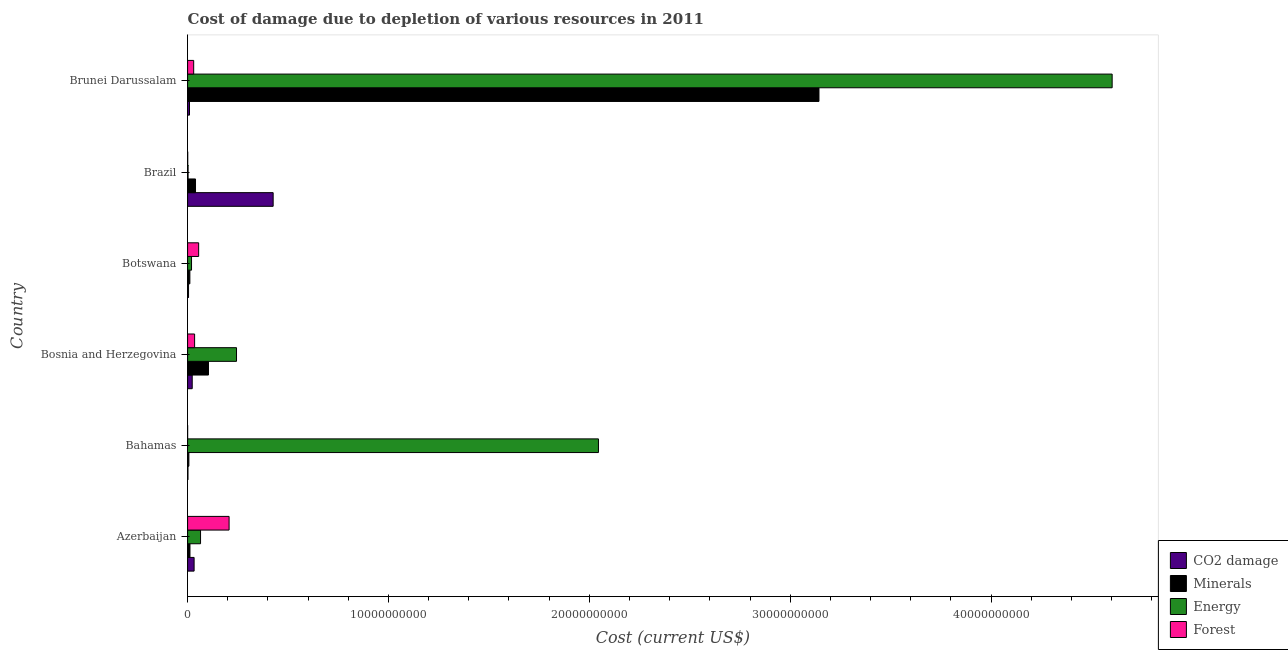Are the number of bars per tick equal to the number of legend labels?
Provide a succinct answer. Yes. How many bars are there on the 1st tick from the top?
Keep it short and to the point. 4. What is the label of the 2nd group of bars from the top?
Offer a terse response. Brazil. In how many cases, is the number of bars for a given country not equal to the number of legend labels?
Your answer should be very brief. 0. What is the cost of damage due to depletion of energy in Brunei Darussalam?
Provide a short and direct response. 4.60e+1. Across all countries, what is the maximum cost of damage due to depletion of forests?
Ensure brevity in your answer.  2.07e+09. Across all countries, what is the minimum cost of damage due to depletion of energy?
Keep it short and to the point. 2.37e+07. In which country was the cost of damage due to depletion of minerals maximum?
Your answer should be very brief. Brunei Darussalam. In which country was the cost of damage due to depletion of forests minimum?
Ensure brevity in your answer.  Bahamas. What is the total cost of damage due to depletion of minerals in the graph?
Offer a terse response. 3.32e+1. What is the difference between the cost of damage due to depletion of coal in Botswana and that in Brunei Darussalam?
Your response must be concise. -4.74e+07. What is the difference between the cost of damage due to depletion of coal in Botswana and the cost of damage due to depletion of energy in Brunei Darussalam?
Provide a short and direct response. -4.60e+1. What is the average cost of damage due to depletion of minerals per country?
Provide a succinct answer. 5.53e+09. What is the difference between the cost of damage due to depletion of energy and cost of damage due to depletion of forests in Brunei Darussalam?
Make the answer very short. 4.57e+1. What is the ratio of the cost of damage due to depletion of forests in Azerbaijan to that in Brazil?
Your response must be concise. 326.15. Is the difference between the cost of damage due to depletion of energy in Azerbaijan and Brunei Darussalam greater than the difference between the cost of damage due to depletion of forests in Azerbaijan and Brunei Darussalam?
Give a very brief answer. No. What is the difference between the highest and the second highest cost of damage due to depletion of minerals?
Give a very brief answer. 3.04e+1. What is the difference between the highest and the lowest cost of damage due to depletion of coal?
Your answer should be compact. 4.24e+09. Is the sum of the cost of damage due to depletion of coal in Azerbaijan and Bosnia and Herzegovina greater than the maximum cost of damage due to depletion of energy across all countries?
Ensure brevity in your answer.  No. What does the 3rd bar from the top in Bahamas represents?
Offer a terse response. Minerals. What does the 1st bar from the bottom in Bosnia and Herzegovina represents?
Give a very brief answer. CO2 damage. How many bars are there?
Give a very brief answer. 24. Are all the bars in the graph horizontal?
Your answer should be very brief. Yes. How many countries are there in the graph?
Provide a succinct answer. 6. Does the graph contain any zero values?
Your answer should be very brief. No. Does the graph contain grids?
Your response must be concise. No. Where does the legend appear in the graph?
Offer a very short reply. Bottom right. How many legend labels are there?
Keep it short and to the point. 4. What is the title of the graph?
Your response must be concise. Cost of damage due to depletion of various resources in 2011 . Does "Periodicity assessment" appear as one of the legend labels in the graph?
Ensure brevity in your answer.  No. What is the label or title of the X-axis?
Offer a very short reply. Cost (current US$). What is the Cost (current US$) in CO2 damage in Azerbaijan?
Provide a short and direct response. 3.24e+08. What is the Cost (current US$) in Minerals in Azerbaijan?
Offer a terse response. 1.18e+08. What is the Cost (current US$) of Energy in Azerbaijan?
Your answer should be compact. 6.45e+08. What is the Cost (current US$) in Forest in Azerbaijan?
Provide a short and direct response. 2.07e+09. What is the Cost (current US$) of CO2 damage in Bahamas?
Your answer should be very brief. 1.85e+07. What is the Cost (current US$) in Minerals in Bahamas?
Provide a succinct answer. 6.40e+07. What is the Cost (current US$) in Energy in Bahamas?
Your answer should be very brief. 2.05e+1. What is the Cost (current US$) in Forest in Bahamas?
Provide a short and direct response. 1.39e+06. What is the Cost (current US$) in CO2 damage in Bosnia and Herzegovina?
Make the answer very short. 2.30e+08. What is the Cost (current US$) of Minerals in Bosnia and Herzegovina?
Give a very brief answer. 1.04e+09. What is the Cost (current US$) of Energy in Bosnia and Herzegovina?
Provide a short and direct response. 2.44e+09. What is the Cost (current US$) in Forest in Bosnia and Herzegovina?
Provide a succinct answer. 3.49e+08. What is the Cost (current US$) of CO2 damage in Botswana?
Offer a terse response. 4.71e+07. What is the Cost (current US$) of Minerals in Botswana?
Provide a short and direct response. 1.13e+08. What is the Cost (current US$) of Energy in Botswana?
Your answer should be compact. 1.96e+08. What is the Cost (current US$) in Forest in Botswana?
Provide a succinct answer. 5.51e+08. What is the Cost (current US$) in CO2 damage in Brazil?
Give a very brief answer. 4.26e+09. What is the Cost (current US$) of Minerals in Brazil?
Give a very brief answer. 3.94e+08. What is the Cost (current US$) in Energy in Brazil?
Offer a very short reply. 2.37e+07. What is the Cost (current US$) of Forest in Brazil?
Ensure brevity in your answer.  6.34e+06. What is the Cost (current US$) of CO2 damage in Brunei Darussalam?
Ensure brevity in your answer.  9.44e+07. What is the Cost (current US$) in Minerals in Brunei Darussalam?
Your answer should be compact. 3.14e+1. What is the Cost (current US$) in Energy in Brunei Darussalam?
Provide a short and direct response. 4.60e+1. What is the Cost (current US$) in Forest in Brunei Darussalam?
Your answer should be very brief. 3.03e+08. Across all countries, what is the maximum Cost (current US$) in CO2 damage?
Offer a very short reply. 4.26e+09. Across all countries, what is the maximum Cost (current US$) of Minerals?
Your answer should be compact. 3.14e+1. Across all countries, what is the maximum Cost (current US$) in Energy?
Your answer should be very brief. 4.60e+1. Across all countries, what is the maximum Cost (current US$) in Forest?
Your response must be concise. 2.07e+09. Across all countries, what is the minimum Cost (current US$) in CO2 damage?
Provide a short and direct response. 1.85e+07. Across all countries, what is the minimum Cost (current US$) of Minerals?
Make the answer very short. 6.40e+07. Across all countries, what is the minimum Cost (current US$) in Energy?
Give a very brief answer. 2.37e+07. Across all countries, what is the minimum Cost (current US$) of Forest?
Offer a very short reply. 1.39e+06. What is the total Cost (current US$) in CO2 damage in the graph?
Make the answer very short. 4.97e+09. What is the total Cost (current US$) of Minerals in the graph?
Give a very brief answer. 3.32e+1. What is the total Cost (current US$) in Energy in the graph?
Provide a succinct answer. 6.98e+1. What is the total Cost (current US$) in Forest in the graph?
Your answer should be very brief. 3.28e+09. What is the difference between the Cost (current US$) in CO2 damage in Azerbaijan and that in Bahamas?
Your answer should be compact. 3.06e+08. What is the difference between the Cost (current US$) of Minerals in Azerbaijan and that in Bahamas?
Ensure brevity in your answer.  5.44e+07. What is the difference between the Cost (current US$) of Energy in Azerbaijan and that in Bahamas?
Your answer should be very brief. -1.98e+1. What is the difference between the Cost (current US$) in Forest in Azerbaijan and that in Bahamas?
Provide a succinct answer. 2.06e+09. What is the difference between the Cost (current US$) in CO2 damage in Azerbaijan and that in Bosnia and Herzegovina?
Give a very brief answer. 9.41e+07. What is the difference between the Cost (current US$) in Minerals in Azerbaijan and that in Bosnia and Herzegovina?
Provide a short and direct response. -9.22e+08. What is the difference between the Cost (current US$) of Energy in Azerbaijan and that in Bosnia and Herzegovina?
Offer a terse response. -1.79e+09. What is the difference between the Cost (current US$) in Forest in Azerbaijan and that in Bosnia and Herzegovina?
Offer a terse response. 1.72e+09. What is the difference between the Cost (current US$) of CO2 damage in Azerbaijan and that in Botswana?
Keep it short and to the point. 2.77e+08. What is the difference between the Cost (current US$) in Minerals in Azerbaijan and that in Botswana?
Your answer should be compact. 5.48e+06. What is the difference between the Cost (current US$) of Energy in Azerbaijan and that in Botswana?
Your answer should be very brief. 4.49e+08. What is the difference between the Cost (current US$) of Forest in Azerbaijan and that in Botswana?
Provide a short and direct response. 1.52e+09. What is the difference between the Cost (current US$) of CO2 damage in Azerbaijan and that in Brazil?
Keep it short and to the point. -3.93e+09. What is the difference between the Cost (current US$) of Minerals in Azerbaijan and that in Brazil?
Make the answer very short. -2.76e+08. What is the difference between the Cost (current US$) of Energy in Azerbaijan and that in Brazil?
Make the answer very short. 6.21e+08. What is the difference between the Cost (current US$) in Forest in Azerbaijan and that in Brazil?
Offer a terse response. 2.06e+09. What is the difference between the Cost (current US$) of CO2 damage in Azerbaijan and that in Brunei Darussalam?
Offer a very short reply. 2.30e+08. What is the difference between the Cost (current US$) in Minerals in Azerbaijan and that in Brunei Darussalam?
Provide a short and direct response. -3.13e+1. What is the difference between the Cost (current US$) in Energy in Azerbaijan and that in Brunei Darussalam?
Make the answer very short. -4.54e+1. What is the difference between the Cost (current US$) of Forest in Azerbaijan and that in Brunei Darussalam?
Provide a succinct answer. 1.76e+09. What is the difference between the Cost (current US$) in CO2 damage in Bahamas and that in Bosnia and Herzegovina?
Your answer should be compact. -2.12e+08. What is the difference between the Cost (current US$) of Minerals in Bahamas and that in Bosnia and Herzegovina?
Offer a terse response. -9.76e+08. What is the difference between the Cost (current US$) in Energy in Bahamas and that in Bosnia and Herzegovina?
Your answer should be very brief. 1.80e+1. What is the difference between the Cost (current US$) of Forest in Bahamas and that in Bosnia and Herzegovina?
Your answer should be very brief. -3.48e+08. What is the difference between the Cost (current US$) of CO2 damage in Bahamas and that in Botswana?
Your answer should be compact. -2.86e+07. What is the difference between the Cost (current US$) in Minerals in Bahamas and that in Botswana?
Keep it short and to the point. -4.89e+07. What is the difference between the Cost (current US$) in Energy in Bahamas and that in Botswana?
Your answer should be very brief. 2.03e+1. What is the difference between the Cost (current US$) of Forest in Bahamas and that in Botswana?
Your response must be concise. -5.49e+08. What is the difference between the Cost (current US$) of CO2 damage in Bahamas and that in Brazil?
Offer a very short reply. -4.24e+09. What is the difference between the Cost (current US$) of Minerals in Bahamas and that in Brazil?
Your answer should be compact. -3.30e+08. What is the difference between the Cost (current US$) in Energy in Bahamas and that in Brazil?
Give a very brief answer. 2.04e+1. What is the difference between the Cost (current US$) in Forest in Bahamas and that in Brazil?
Give a very brief answer. -4.94e+06. What is the difference between the Cost (current US$) of CO2 damage in Bahamas and that in Brunei Darussalam?
Offer a terse response. -7.60e+07. What is the difference between the Cost (current US$) in Minerals in Bahamas and that in Brunei Darussalam?
Keep it short and to the point. -3.14e+1. What is the difference between the Cost (current US$) in Energy in Bahamas and that in Brunei Darussalam?
Offer a terse response. -2.56e+1. What is the difference between the Cost (current US$) in Forest in Bahamas and that in Brunei Darussalam?
Give a very brief answer. -3.02e+08. What is the difference between the Cost (current US$) in CO2 damage in Bosnia and Herzegovina and that in Botswana?
Provide a short and direct response. 1.83e+08. What is the difference between the Cost (current US$) of Minerals in Bosnia and Herzegovina and that in Botswana?
Ensure brevity in your answer.  9.27e+08. What is the difference between the Cost (current US$) in Energy in Bosnia and Herzegovina and that in Botswana?
Your answer should be compact. 2.24e+09. What is the difference between the Cost (current US$) of Forest in Bosnia and Herzegovina and that in Botswana?
Ensure brevity in your answer.  -2.02e+08. What is the difference between the Cost (current US$) of CO2 damage in Bosnia and Herzegovina and that in Brazil?
Ensure brevity in your answer.  -4.03e+09. What is the difference between the Cost (current US$) in Minerals in Bosnia and Herzegovina and that in Brazil?
Your answer should be very brief. 6.46e+08. What is the difference between the Cost (current US$) in Energy in Bosnia and Herzegovina and that in Brazil?
Make the answer very short. 2.41e+09. What is the difference between the Cost (current US$) in Forest in Bosnia and Herzegovina and that in Brazil?
Provide a short and direct response. 3.43e+08. What is the difference between the Cost (current US$) of CO2 damage in Bosnia and Herzegovina and that in Brunei Darussalam?
Your response must be concise. 1.36e+08. What is the difference between the Cost (current US$) of Minerals in Bosnia and Herzegovina and that in Brunei Darussalam?
Provide a short and direct response. -3.04e+1. What is the difference between the Cost (current US$) of Energy in Bosnia and Herzegovina and that in Brunei Darussalam?
Keep it short and to the point. -4.36e+1. What is the difference between the Cost (current US$) in Forest in Bosnia and Herzegovina and that in Brunei Darussalam?
Give a very brief answer. 4.58e+07. What is the difference between the Cost (current US$) in CO2 damage in Botswana and that in Brazil?
Give a very brief answer. -4.21e+09. What is the difference between the Cost (current US$) of Minerals in Botswana and that in Brazil?
Offer a terse response. -2.81e+08. What is the difference between the Cost (current US$) in Energy in Botswana and that in Brazil?
Give a very brief answer. 1.72e+08. What is the difference between the Cost (current US$) in Forest in Botswana and that in Brazil?
Keep it short and to the point. 5.44e+08. What is the difference between the Cost (current US$) of CO2 damage in Botswana and that in Brunei Darussalam?
Make the answer very short. -4.74e+07. What is the difference between the Cost (current US$) in Minerals in Botswana and that in Brunei Darussalam?
Offer a terse response. -3.13e+1. What is the difference between the Cost (current US$) in Energy in Botswana and that in Brunei Darussalam?
Keep it short and to the point. -4.58e+1. What is the difference between the Cost (current US$) of Forest in Botswana and that in Brunei Darussalam?
Your answer should be very brief. 2.47e+08. What is the difference between the Cost (current US$) of CO2 damage in Brazil and that in Brunei Darussalam?
Make the answer very short. 4.16e+09. What is the difference between the Cost (current US$) in Minerals in Brazil and that in Brunei Darussalam?
Your answer should be very brief. -3.10e+1. What is the difference between the Cost (current US$) in Energy in Brazil and that in Brunei Darussalam?
Your answer should be very brief. -4.60e+1. What is the difference between the Cost (current US$) in Forest in Brazil and that in Brunei Darussalam?
Offer a very short reply. -2.97e+08. What is the difference between the Cost (current US$) of CO2 damage in Azerbaijan and the Cost (current US$) of Minerals in Bahamas?
Make the answer very short. 2.60e+08. What is the difference between the Cost (current US$) in CO2 damage in Azerbaijan and the Cost (current US$) in Energy in Bahamas?
Your answer should be compact. -2.01e+1. What is the difference between the Cost (current US$) in CO2 damage in Azerbaijan and the Cost (current US$) in Forest in Bahamas?
Give a very brief answer. 3.23e+08. What is the difference between the Cost (current US$) of Minerals in Azerbaijan and the Cost (current US$) of Energy in Bahamas?
Provide a succinct answer. -2.03e+1. What is the difference between the Cost (current US$) of Minerals in Azerbaijan and the Cost (current US$) of Forest in Bahamas?
Offer a very short reply. 1.17e+08. What is the difference between the Cost (current US$) in Energy in Azerbaijan and the Cost (current US$) in Forest in Bahamas?
Provide a short and direct response. 6.43e+08. What is the difference between the Cost (current US$) in CO2 damage in Azerbaijan and the Cost (current US$) in Minerals in Bosnia and Herzegovina?
Provide a short and direct response. -7.16e+08. What is the difference between the Cost (current US$) of CO2 damage in Azerbaijan and the Cost (current US$) of Energy in Bosnia and Herzegovina?
Your response must be concise. -2.11e+09. What is the difference between the Cost (current US$) of CO2 damage in Azerbaijan and the Cost (current US$) of Forest in Bosnia and Herzegovina?
Make the answer very short. -2.47e+07. What is the difference between the Cost (current US$) in Minerals in Azerbaijan and the Cost (current US$) in Energy in Bosnia and Herzegovina?
Offer a terse response. -2.32e+09. What is the difference between the Cost (current US$) in Minerals in Azerbaijan and the Cost (current US$) in Forest in Bosnia and Herzegovina?
Your response must be concise. -2.31e+08. What is the difference between the Cost (current US$) of Energy in Azerbaijan and the Cost (current US$) of Forest in Bosnia and Herzegovina?
Offer a very short reply. 2.96e+08. What is the difference between the Cost (current US$) of CO2 damage in Azerbaijan and the Cost (current US$) of Minerals in Botswana?
Keep it short and to the point. 2.11e+08. What is the difference between the Cost (current US$) of CO2 damage in Azerbaijan and the Cost (current US$) of Energy in Botswana?
Ensure brevity in your answer.  1.28e+08. What is the difference between the Cost (current US$) in CO2 damage in Azerbaijan and the Cost (current US$) in Forest in Botswana?
Provide a short and direct response. -2.26e+08. What is the difference between the Cost (current US$) in Minerals in Azerbaijan and the Cost (current US$) in Energy in Botswana?
Offer a very short reply. -7.77e+07. What is the difference between the Cost (current US$) of Minerals in Azerbaijan and the Cost (current US$) of Forest in Botswana?
Offer a terse response. -4.32e+08. What is the difference between the Cost (current US$) in Energy in Azerbaijan and the Cost (current US$) in Forest in Botswana?
Your answer should be very brief. 9.40e+07. What is the difference between the Cost (current US$) in CO2 damage in Azerbaijan and the Cost (current US$) in Minerals in Brazil?
Your answer should be very brief. -6.99e+07. What is the difference between the Cost (current US$) of CO2 damage in Azerbaijan and the Cost (current US$) of Energy in Brazil?
Provide a short and direct response. 3.01e+08. What is the difference between the Cost (current US$) in CO2 damage in Azerbaijan and the Cost (current US$) in Forest in Brazil?
Give a very brief answer. 3.18e+08. What is the difference between the Cost (current US$) in Minerals in Azerbaijan and the Cost (current US$) in Energy in Brazil?
Offer a very short reply. 9.47e+07. What is the difference between the Cost (current US$) of Minerals in Azerbaijan and the Cost (current US$) of Forest in Brazil?
Make the answer very short. 1.12e+08. What is the difference between the Cost (current US$) of Energy in Azerbaijan and the Cost (current US$) of Forest in Brazil?
Provide a succinct answer. 6.38e+08. What is the difference between the Cost (current US$) in CO2 damage in Azerbaijan and the Cost (current US$) in Minerals in Brunei Darussalam?
Your answer should be compact. -3.11e+1. What is the difference between the Cost (current US$) of CO2 damage in Azerbaijan and the Cost (current US$) of Energy in Brunei Darussalam?
Make the answer very short. -4.57e+1. What is the difference between the Cost (current US$) of CO2 damage in Azerbaijan and the Cost (current US$) of Forest in Brunei Darussalam?
Give a very brief answer. 2.11e+07. What is the difference between the Cost (current US$) of Minerals in Azerbaijan and the Cost (current US$) of Energy in Brunei Darussalam?
Your answer should be compact. -4.59e+1. What is the difference between the Cost (current US$) of Minerals in Azerbaijan and the Cost (current US$) of Forest in Brunei Darussalam?
Your answer should be compact. -1.85e+08. What is the difference between the Cost (current US$) of Energy in Azerbaijan and the Cost (current US$) of Forest in Brunei Darussalam?
Make the answer very short. 3.41e+08. What is the difference between the Cost (current US$) of CO2 damage in Bahamas and the Cost (current US$) of Minerals in Bosnia and Herzegovina?
Ensure brevity in your answer.  -1.02e+09. What is the difference between the Cost (current US$) of CO2 damage in Bahamas and the Cost (current US$) of Energy in Bosnia and Herzegovina?
Provide a succinct answer. -2.42e+09. What is the difference between the Cost (current US$) in CO2 damage in Bahamas and the Cost (current US$) in Forest in Bosnia and Herzegovina?
Give a very brief answer. -3.31e+08. What is the difference between the Cost (current US$) in Minerals in Bahamas and the Cost (current US$) in Energy in Bosnia and Herzegovina?
Provide a succinct answer. -2.37e+09. What is the difference between the Cost (current US$) in Minerals in Bahamas and the Cost (current US$) in Forest in Bosnia and Herzegovina?
Keep it short and to the point. -2.85e+08. What is the difference between the Cost (current US$) in Energy in Bahamas and the Cost (current US$) in Forest in Bosnia and Herzegovina?
Keep it short and to the point. 2.01e+1. What is the difference between the Cost (current US$) in CO2 damage in Bahamas and the Cost (current US$) in Minerals in Botswana?
Offer a very short reply. -9.44e+07. What is the difference between the Cost (current US$) in CO2 damage in Bahamas and the Cost (current US$) in Energy in Botswana?
Your response must be concise. -1.78e+08. What is the difference between the Cost (current US$) of CO2 damage in Bahamas and the Cost (current US$) of Forest in Botswana?
Provide a succinct answer. -5.32e+08. What is the difference between the Cost (current US$) of Minerals in Bahamas and the Cost (current US$) of Energy in Botswana?
Your response must be concise. -1.32e+08. What is the difference between the Cost (current US$) in Minerals in Bahamas and the Cost (current US$) in Forest in Botswana?
Ensure brevity in your answer.  -4.87e+08. What is the difference between the Cost (current US$) in Energy in Bahamas and the Cost (current US$) in Forest in Botswana?
Your answer should be very brief. 1.99e+1. What is the difference between the Cost (current US$) of CO2 damage in Bahamas and the Cost (current US$) of Minerals in Brazil?
Your answer should be compact. -3.76e+08. What is the difference between the Cost (current US$) in CO2 damage in Bahamas and the Cost (current US$) in Energy in Brazil?
Offer a terse response. -5.18e+06. What is the difference between the Cost (current US$) of CO2 damage in Bahamas and the Cost (current US$) of Forest in Brazil?
Offer a very short reply. 1.21e+07. What is the difference between the Cost (current US$) of Minerals in Bahamas and the Cost (current US$) of Energy in Brazil?
Provide a short and direct response. 4.03e+07. What is the difference between the Cost (current US$) in Minerals in Bahamas and the Cost (current US$) in Forest in Brazil?
Make the answer very short. 5.77e+07. What is the difference between the Cost (current US$) in Energy in Bahamas and the Cost (current US$) in Forest in Brazil?
Keep it short and to the point. 2.04e+1. What is the difference between the Cost (current US$) in CO2 damage in Bahamas and the Cost (current US$) in Minerals in Brunei Darussalam?
Provide a short and direct response. -3.14e+1. What is the difference between the Cost (current US$) of CO2 damage in Bahamas and the Cost (current US$) of Energy in Brunei Darussalam?
Make the answer very short. -4.60e+1. What is the difference between the Cost (current US$) of CO2 damage in Bahamas and the Cost (current US$) of Forest in Brunei Darussalam?
Provide a short and direct response. -2.85e+08. What is the difference between the Cost (current US$) of Minerals in Bahamas and the Cost (current US$) of Energy in Brunei Darussalam?
Your answer should be very brief. -4.60e+1. What is the difference between the Cost (current US$) of Minerals in Bahamas and the Cost (current US$) of Forest in Brunei Darussalam?
Your response must be concise. -2.39e+08. What is the difference between the Cost (current US$) in Energy in Bahamas and the Cost (current US$) in Forest in Brunei Darussalam?
Your answer should be very brief. 2.02e+1. What is the difference between the Cost (current US$) of CO2 damage in Bosnia and Herzegovina and the Cost (current US$) of Minerals in Botswana?
Your answer should be compact. 1.17e+08. What is the difference between the Cost (current US$) of CO2 damage in Bosnia and Herzegovina and the Cost (current US$) of Energy in Botswana?
Offer a terse response. 3.40e+07. What is the difference between the Cost (current US$) in CO2 damage in Bosnia and Herzegovina and the Cost (current US$) in Forest in Botswana?
Your response must be concise. -3.20e+08. What is the difference between the Cost (current US$) of Minerals in Bosnia and Herzegovina and the Cost (current US$) of Energy in Botswana?
Offer a very short reply. 8.44e+08. What is the difference between the Cost (current US$) in Minerals in Bosnia and Herzegovina and the Cost (current US$) in Forest in Botswana?
Your answer should be compact. 4.90e+08. What is the difference between the Cost (current US$) in Energy in Bosnia and Herzegovina and the Cost (current US$) in Forest in Botswana?
Your answer should be compact. 1.88e+09. What is the difference between the Cost (current US$) of CO2 damage in Bosnia and Herzegovina and the Cost (current US$) of Minerals in Brazil?
Keep it short and to the point. -1.64e+08. What is the difference between the Cost (current US$) of CO2 damage in Bosnia and Herzegovina and the Cost (current US$) of Energy in Brazil?
Provide a short and direct response. 2.07e+08. What is the difference between the Cost (current US$) of CO2 damage in Bosnia and Herzegovina and the Cost (current US$) of Forest in Brazil?
Ensure brevity in your answer.  2.24e+08. What is the difference between the Cost (current US$) in Minerals in Bosnia and Herzegovina and the Cost (current US$) in Energy in Brazil?
Provide a short and direct response. 1.02e+09. What is the difference between the Cost (current US$) in Minerals in Bosnia and Herzegovina and the Cost (current US$) in Forest in Brazil?
Give a very brief answer. 1.03e+09. What is the difference between the Cost (current US$) of Energy in Bosnia and Herzegovina and the Cost (current US$) of Forest in Brazil?
Give a very brief answer. 2.43e+09. What is the difference between the Cost (current US$) of CO2 damage in Bosnia and Herzegovina and the Cost (current US$) of Minerals in Brunei Darussalam?
Give a very brief answer. -3.12e+1. What is the difference between the Cost (current US$) of CO2 damage in Bosnia and Herzegovina and the Cost (current US$) of Energy in Brunei Darussalam?
Provide a short and direct response. -4.58e+1. What is the difference between the Cost (current US$) in CO2 damage in Bosnia and Herzegovina and the Cost (current US$) in Forest in Brunei Darussalam?
Offer a very short reply. -7.31e+07. What is the difference between the Cost (current US$) of Minerals in Bosnia and Herzegovina and the Cost (current US$) of Energy in Brunei Darussalam?
Give a very brief answer. -4.50e+1. What is the difference between the Cost (current US$) in Minerals in Bosnia and Herzegovina and the Cost (current US$) in Forest in Brunei Darussalam?
Provide a short and direct response. 7.37e+08. What is the difference between the Cost (current US$) of Energy in Bosnia and Herzegovina and the Cost (current US$) of Forest in Brunei Darussalam?
Your answer should be very brief. 2.13e+09. What is the difference between the Cost (current US$) of CO2 damage in Botswana and the Cost (current US$) of Minerals in Brazil?
Offer a terse response. -3.47e+08. What is the difference between the Cost (current US$) of CO2 damage in Botswana and the Cost (current US$) of Energy in Brazil?
Offer a very short reply. 2.34e+07. What is the difference between the Cost (current US$) of CO2 damage in Botswana and the Cost (current US$) of Forest in Brazil?
Make the answer very short. 4.07e+07. What is the difference between the Cost (current US$) of Minerals in Botswana and the Cost (current US$) of Energy in Brazil?
Your answer should be compact. 8.93e+07. What is the difference between the Cost (current US$) in Minerals in Botswana and the Cost (current US$) in Forest in Brazil?
Ensure brevity in your answer.  1.07e+08. What is the difference between the Cost (current US$) in Energy in Botswana and the Cost (current US$) in Forest in Brazil?
Your response must be concise. 1.90e+08. What is the difference between the Cost (current US$) of CO2 damage in Botswana and the Cost (current US$) of Minerals in Brunei Darussalam?
Keep it short and to the point. -3.14e+1. What is the difference between the Cost (current US$) of CO2 damage in Botswana and the Cost (current US$) of Energy in Brunei Darussalam?
Make the answer very short. -4.60e+1. What is the difference between the Cost (current US$) in CO2 damage in Botswana and the Cost (current US$) in Forest in Brunei Darussalam?
Your answer should be very brief. -2.56e+08. What is the difference between the Cost (current US$) in Minerals in Botswana and the Cost (current US$) in Energy in Brunei Darussalam?
Your response must be concise. -4.59e+1. What is the difference between the Cost (current US$) in Minerals in Botswana and the Cost (current US$) in Forest in Brunei Darussalam?
Make the answer very short. -1.90e+08. What is the difference between the Cost (current US$) of Energy in Botswana and the Cost (current US$) of Forest in Brunei Darussalam?
Give a very brief answer. -1.07e+08. What is the difference between the Cost (current US$) of CO2 damage in Brazil and the Cost (current US$) of Minerals in Brunei Darussalam?
Give a very brief answer. -2.72e+1. What is the difference between the Cost (current US$) in CO2 damage in Brazil and the Cost (current US$) in Energy in Brunei Darussalam?
Offer a very short reply. -4.18e+1. What is the difference between the Cost (current US$) in CO2 damage in Brazil and the Cost (current US$) in Forest in Brunei Darussalam?
Your answer should be compact. 3.96e+09. What is the difference between the Cost (current US$) in Minerals in Brazil and the Cost (current US$) in Energy in Brunei Darussalam?
Provide a succinct answer. -4.56e+1. What is the difference between the Cost (current US$) of Minerals in Brazil and the Cost (current US$) of Forest in Brunei Darussalam?
Give a very brief answer. 9.10e+07. What is the difference between the Cost (current US$) in Energy in Brazil and the Cost (current US$) in Forest in Brunei Darussalam?
Ensure brevity in your answer.  -2.80e+08. What is the average Cost (current US$) of CO2 damage per country?
Provide a succinct answer. 8.29e+08. What is the average Cost (current US$) in Minerals per country?
Provide a succinct answer. 5.53e+09. What is the average Cost (current US$) in Energy per country?
Your answer should be compact. 1.16e+1. What is the average Cost (current US$) of Forest per country?
Provide a succinct answer. 5.46e+08. What is the difference between the Cost (current US$) of CO2 damage and Cost (current US$) of Minerals in Azerbaijan?
Your answer should be very brief. 2.06e+08. What is the difference between the Cost (current US$) in CO2 damage and Cost (current US$) in Energy in Azerbaijan?
Ensure brevity in your answer.  -3.20e+08. What is the difference between the Cost (current US$) of CO2 damage and Cost (current US$) of Forest in Azerbaijan?
Make the answer very short. -1.74e+09. What is the difference between the Cost (current US$) in Minerals and Cost (current US$) in Energy in Azerbaijan?
Provide a short and direct response. -5.26e+08. What is the difference between the Cost (current US$) in Minerals and Cost (current US$) in Forest in Azerbaijan?
Keep it short and to the point. -1.95e+09. What is the difference between the Cost (current US$) in Energy and Cost (current US$) in Forest in Azerbaijan?
Your response must be concise. -1.42e+09. What is the difference between the Cost (current US$) in CO2 damage and Cost (current US$) in Minerals in Bahamas?
Keep it short and to the point. -4.55e+07. What is the difference between the Cost (current US$) of CO2 damage and Cost (current US$) of Energy in Bahamas?
Your response must be concise. -2.04e+1. What is the difference between the Cost (current US$) in CO2 damage and Cost (current US$) in Forest in Bahamas?
Make the answer very short. 1.71e+07. What is the difference between the Cost (current US$) of Minerals and Cost (current US$) of Energy in Bahamas?
Your answer should be compact. -2.04e+1. What is the difference between the Cost (current US$) in Minerals and Cost (current US$) in Forest in Bahamas?
Make the answer very short. 6.26e+07. What is the difference between the Cost (current US$) of Energy and Cost (current US$) of Forest in Bahamas?
Your answer should be compact. 2.05e+1. What is the difference between the Cost (current US$) of CO2 damage and Cost (current US$) of Minerals in Bosnia and Herzegovina?
Keep it short and to the point. -8.10e+08. What is the difference between the Cost (current US$) of CO2 damage and Cost (current US$) of Energy in Bosnia and Herzegovina?
Your response must be concise. -2.21e+09. What is the difference between the Cost (current US$) in CO2 damage and Cost (current US$) in Forest in Bosnia and Herzegovina?
Your answer should be very brief. -1.19e+08. What is the difference between the Cost (current US$) in Minerals and Cost (current US$) in Energy in Bosnia and Herzegovina?
Ensure brevity in your answer.  -1.40e+09. What is the difference between the Cost (current US$) in Minerals and Cost (current US$) in Forest in Bosnia and Herzegovina?
Make the answer very short. 6.91e+08. What is the difference between the Cost (current US$) in Energy and Cost (current US$) in Forest in Bosnia and Herzegovina?
Offer a terse response. 2.09e+09. What is the difference between the Cost (current US$) in CO2 damage and Cost (current US$) in Minerals in Botswana?
Ensure brevity in your answer.  -6.59e+07. What is the difference between the Cost (current US$) of CO2 damage and Cost (current US$) of Energy in Botswana?
Keep it short and to the point. -1.49e+08. What is the difference between the Cost (current US$) in CO2 damage and Cost (current US$) in Forest in Botswana?
Give a very brief answer. -5.04e+08. What is the difference between the Cost (current US$) of Minerals and Cost (current US$) of Energy in Botswana?
Ensure brevity in your answer.  -8.32e+07. What is the difference between the Cost (current US$) of Minerals and Cost (current US$) of Forest in Botswana?
Your answer should be compact. -4.38e+08. What is the difference between the Cost (current US$) in Energy and Cost (current US$) in Forest in Botswana?
Offer a very short reply. -3.55e+08. What is the difference between the Cost (current US$) of CO2 damage and Cost (current US$) of Minerals in Brazil?
Offer a very short reply. 3.86e+09. What is the difference between the Cost (current US$) of CO2 damage and Cost (current US$) of Energy in Brazil?
Make the answer very short. 4.24e+09. What is the difference between the Cost (current US$) in CO2 damage and Cost (current US$) in Forest in Brazil?
Your answer should be compact. 4.25e+09. What is the difference between the Cost (current US$) in Minerals and Cost (current US$) in Energy in Brazil?
Your answer should be compact. 3.71e+08. What is the difference between the Cost (current US$) of Minerals and Cost (current US$) of Forest in Brazil?
Keep it short and to the point. 3.88e+08. What is the difference between the Cost (current US$) in Energy and Cost (current US$) in Forest in Brazil?
Make the answer very short. 1.73e+07. What is the difference between the Cost (current US$) in CO2 damage and Cost (current US$) in Minerals in Brunei Darussalam?
Your answer should be compact. -3.13e+1. What is the difference between the Cost (current US$) in CO2 damage and Cost (current US$) in Energy in Brunei Darussalam?
Your answer should be very brief. -4.59e+1. What is the difference between the Cost (current US$) in CO2 damage and Cost (current US$) in Forest in Brunei Darussalam?
Give a very brief answer. -2.09e+08. What is the difference between the Cost (current US$) in Minerals and Cost (current US$) in Energy in Brunei Darussalam?
Make the answer very short. -1.46e+1. What is the difference between the Cost (current US$) in Minerals and Cost (current US$) in Forest in Brunei Darussalam?
Provide a succinct answer. 3.11e+1. What is the difference between the Cost (current US$) of Energy and Cost (current US$) of Forest in Brunei Darussalam?
Your answer should be very brief. 4.57e+1. What is the ratio of the Cost (current US$) in CO2 damage in Azerbaijan to that in Bahamas?
Give a very brief answer. 17.55. What is the ratio of the Cost (current US$) of Minerals in Azerbaijan to that in Bahamas?
Your answer should be compact. 1.85. What is the ratio of the Cost (current US$) in Energy in Azerbaijan to that in Bahamas?
Your answer should be very brief. 0.03. What is the ratio of the Cost (current US$) in Forest in Azerbaijan to that in Bahamas?
Give a very brief answer. 1484.32. What is the ratio of the Cost (current US$) of CO2 damage in Azerbaijan to that in Bosnia and Herzegovina?
Ensure brevity in your answer.  1.41. What is the ratio of the Cost (current US$) in Minerals in Azerbaijan to that in Bosnia and Herzegovina?
Give a very brief answer. 0.11. What is the ratio of the Cost (current US$) of Energy in Azerbaijan to that in Bosnia and Herzegovina?
Provide a succinct answer. 0.26. What is the ratio of the Cost (current US$) in Forest in Azerbaijan to that in Bosnia and Herzegovina?
Offer a terse response. 5.92. What is the ratio of the Cost (current US$) of CO2 damage in Azerbaijan to that in Botswana?
Offer a terse response. 6.89. What is the ratio of the Cost (current US$) of Minerals in Azerbaijan to that in Botswana?
Ensure brevity in your answer.  1.05. What is the ratio of the Cost (current US$) of Energy in Azerbaijan to that in Botswana?
Your response must be concise. 3.29. What is the ratio of the Cost (current US$) in Forest in Azerbaijan to that in Botswana?
Offer a terse response. 3.75. What is the ratio of the Cost (current US$) of CO2 damage in Azerbaijan to that in Brazil?
Provide a succinct answer. 0.08. What is the ratio of the Cost (current US$) in Minerals in Azerbaijan to that in Brazil?
Ensure brevity in your answer.  0.3. What is the ratio of the Cost (current US$) of Energy in Azerbaijan to that in Brazil?
Offer a very short reply. 27.25. What is the ratio of the Cost (current US$) of Forest in Azerbaijan to that in Brazil?
Keep it short and to the point. 326.15. What is the ratio of the Cost (current US$) of CO2 damage in Azerbaijan to that in Brunei Darussalam?
Ensure brevity in your answer.  3.43. What is the ratio of the Cost (current US$) in Minerals in Azerbaijan to that in Brunei Darussalam?
Your response must be concise. 0. What is the ratio of the Cost (current US$) in Energy in Azerbaijan to that in Brunei Darussalam?
Your answer should be very brief. 0.01. What is the ratio of the Cost (current US$) in Forest in Azerbaijan to that in Brunei Darussalam?
Your answer should be compact. 6.81. What is the ratio of the Cost (current US$) of CO2 damage in Bahamas to that in Bosnia and Herzegovina?
Give a very brief answer. 0.08. What is the ratio of the Cost (current US$) in Minerals in Bahamas to that in Bosnia and Herzegovina?
Offer a very short reply. 0.06. What is the ratio of the Cost (current US$) in Energy in Bahamas to that in Bosnia and Herzegovina?
Offer a terse response. 8.4. What is the ratio of the Cost (current US$) in Forest in Bahamas to that in Bosnia and Herzegovina?
Offer a very short reply. 0. What is the ratio of the Cost (current US$) in CO2 damage in Bahamas to that in Botswana?
Provide a succinct answer. 0.39. What is the ratio of the Cost (current US$) of Minerals in Bahamas to that in Botswana?
Offer a very short reply. 0.57. What is the ratio of the Cost (current US$) in Energy in Bahamas to that in Botswana?
Provide a succinct answer. 104.28. What is the ratio of the Cost (current US$) in Forest in Bahamas to that in Botswana?
Keep it short and to the point. 0. What is the ratio of the Cost (current US$) in CO2 damage in Bahamas to that in Brazil?
Provide a succinct answer. 0. What is the ratio of the Cost (current US$) of Minerals in Bahamas to that in Brazil?
Provide a short and direct response. 0.16. What is the ratio of the Cost (current US$) in Energy in Bahamas to that in Brazil?
Provide a succinct answer. 864.52. What is the ratio of the Cost (current US$) of Forest in Bahamas to that in Brazil?
Offer a terse response. 0.22. What is the ratio of the Cost (current US$) in CO2 damage in Bahamas to that in Brunei Darussalam?
Provide a succinct answer. 0.2. What is the ratio of the Cost (current US$) of Minerals in Bahamas to that in Brunei Darussalam?
Ensure brevity in your answer.  0. What is the ratio of the Cost (current US$) of Energy in Bahamas to that in Brunei Darussalam?
Keep it short and to the point. 0.44. What is the ratio of the Cost (current US$) in Forest in Bahamas to that in Brunei Darussalam?
Your response must be concise. 0. What is the ratio of the Cost (current US$) of CO2 damage in Bosnia and Herzegovina to that in Botswana?
Ensure brevity in your answer.  4.89. What is the ratio of the Cost (current US$) of Minerals in Bosnia and Herzegovina to that in Botswana?
Ensure brevity in your answer.  9.21. What is the ratio of the Cost (current US$) in Energy in Bosnia and Herzegovina to that in Botswana?
Offer a very short reply. 12.42. What is the ratio of the Cost (current US$) of Forest in Bosnia and Herzegovina to that in Botswana?
Offer a very short reply. 0.63. What is the ratio of the Cost (current US$) of CO2 damage in Bosnia and Herzegovina to that in Brazil?
Your response must be concise. 0.05. What is the ratio of the Cost (current US$) in Minerals in Bosnia and Herzegovina to that in Brazil?
Give a very brief answer. 2.64. What is the ratio of the Cost (current US$) of Energy in Bosnia and Herzegovina to that in Brazil?
Your answer should be very brief. 102.93. What is the ratio of the Cost (current US$) in Forest in Bosnia and Herzegovina to that in Brazil?
Your answer should be compact. 55.09. What is the ratio of the Cost (current US$) of CO2 damage in Bosnia and Herzegovina to that in Brunei Darussalam?
Ensure brevity in your answer.  2.44. What is the ratio of the Cost (current US$) in Minerals in Bosnia and Herzegovina to that in Brunei Darussalam?
Keep it short and to the point. 0.03. What is the ratio of the Cost (current US$) in Energy in Bosnia and Herzegovina to that in Brunei Darussalam?
Your answer should be very brief. 0.05. What is the ratio of the Cost (current US$) of Forest in Bosnia and Herzegovina to that in Brunei Darussalam?
Ensure brevity in your answer.  1.15. What is the ratio of the Cost (current US$) in CO2 damage in Botswana to that in Brazil?
Your answer should be very brief. 0.01. What is the ratio of the Cost (current US$) in Minerals in Botswana to that in Brazil?
Your answer should be compact. 0.29. What is the ratio of the Cost (current US$) of Energy in Botswana to that in Brazil?
Give a very brief answer. 8.29. What is the ratio of the Cost (current US$) in Forest in Botswana to that in Brazil?
Your response must be concise. 86.92. What is the ratio of the Cost (current US$) in CO2 damage in Botswana to that in Brunei Darussalam?
Your answer should be very brief. 0.5. What is the ratio of the Cost (current US$) of Minerals in Botswana to that in Brunei Darussalam?
Keep it short and to the point. 0. What is the ratio of the Cost (current US$) in Energy in Botswana to that in Brunei Darussalam?
Keep it short and to the point. 0. What is the ratio of the Cost (current US$) of Forest in Botswana to that in Brunei Darussalam?
Your answer should be very brief. 1.82. What is the ratio of the Cost (current US$) in CO2 damage in Brazil to that in Brunei Darussalam?
Provide a short and direct response. 45.1. What is the ratio of the Cost (current US$) of Minerals in Brazil to that in Brunei Darussalam?
Your answer should be compact. 0.01. What is the ratio of the Cost (current US$) of Forest in Brazil to that in Brunei Darussalam?
Offer a very short reply. 0.02. What is the difference between the highest and the second highest Cost (current US$) of CO2 damage?
Offer a very short reply. 3.93e+09. What is the difference between the highest and the second highest Cost (current US$) in Minerals?
Your response must be concise. 3.04e+1. What is the difference between the highest and the second highest Cost (current US$) in Energy?
Provide a short and direct response. 2.56e+1. What is the difference between the highest and the second highest Cost (current US$) of Forest?
Your answer should be very brief. 1.52e+09. What is the difference between the highest and the lowest Cost (current US$) of CO2 damage?
Your response must be concise. 4.24e+09. What is the difference between the highest and the lowest Cost (current US$) of Minerals?
Keep it short and to the point. 3.14e+1. What is the difference between the highest and the lowest Cost (current US$) of Energy?
Provide a short and direct response. 4.60e+1. What is the difference between the highest and the lowest Cost (current US$) of Forest?
Make the answer very short. 2.06e+09. 